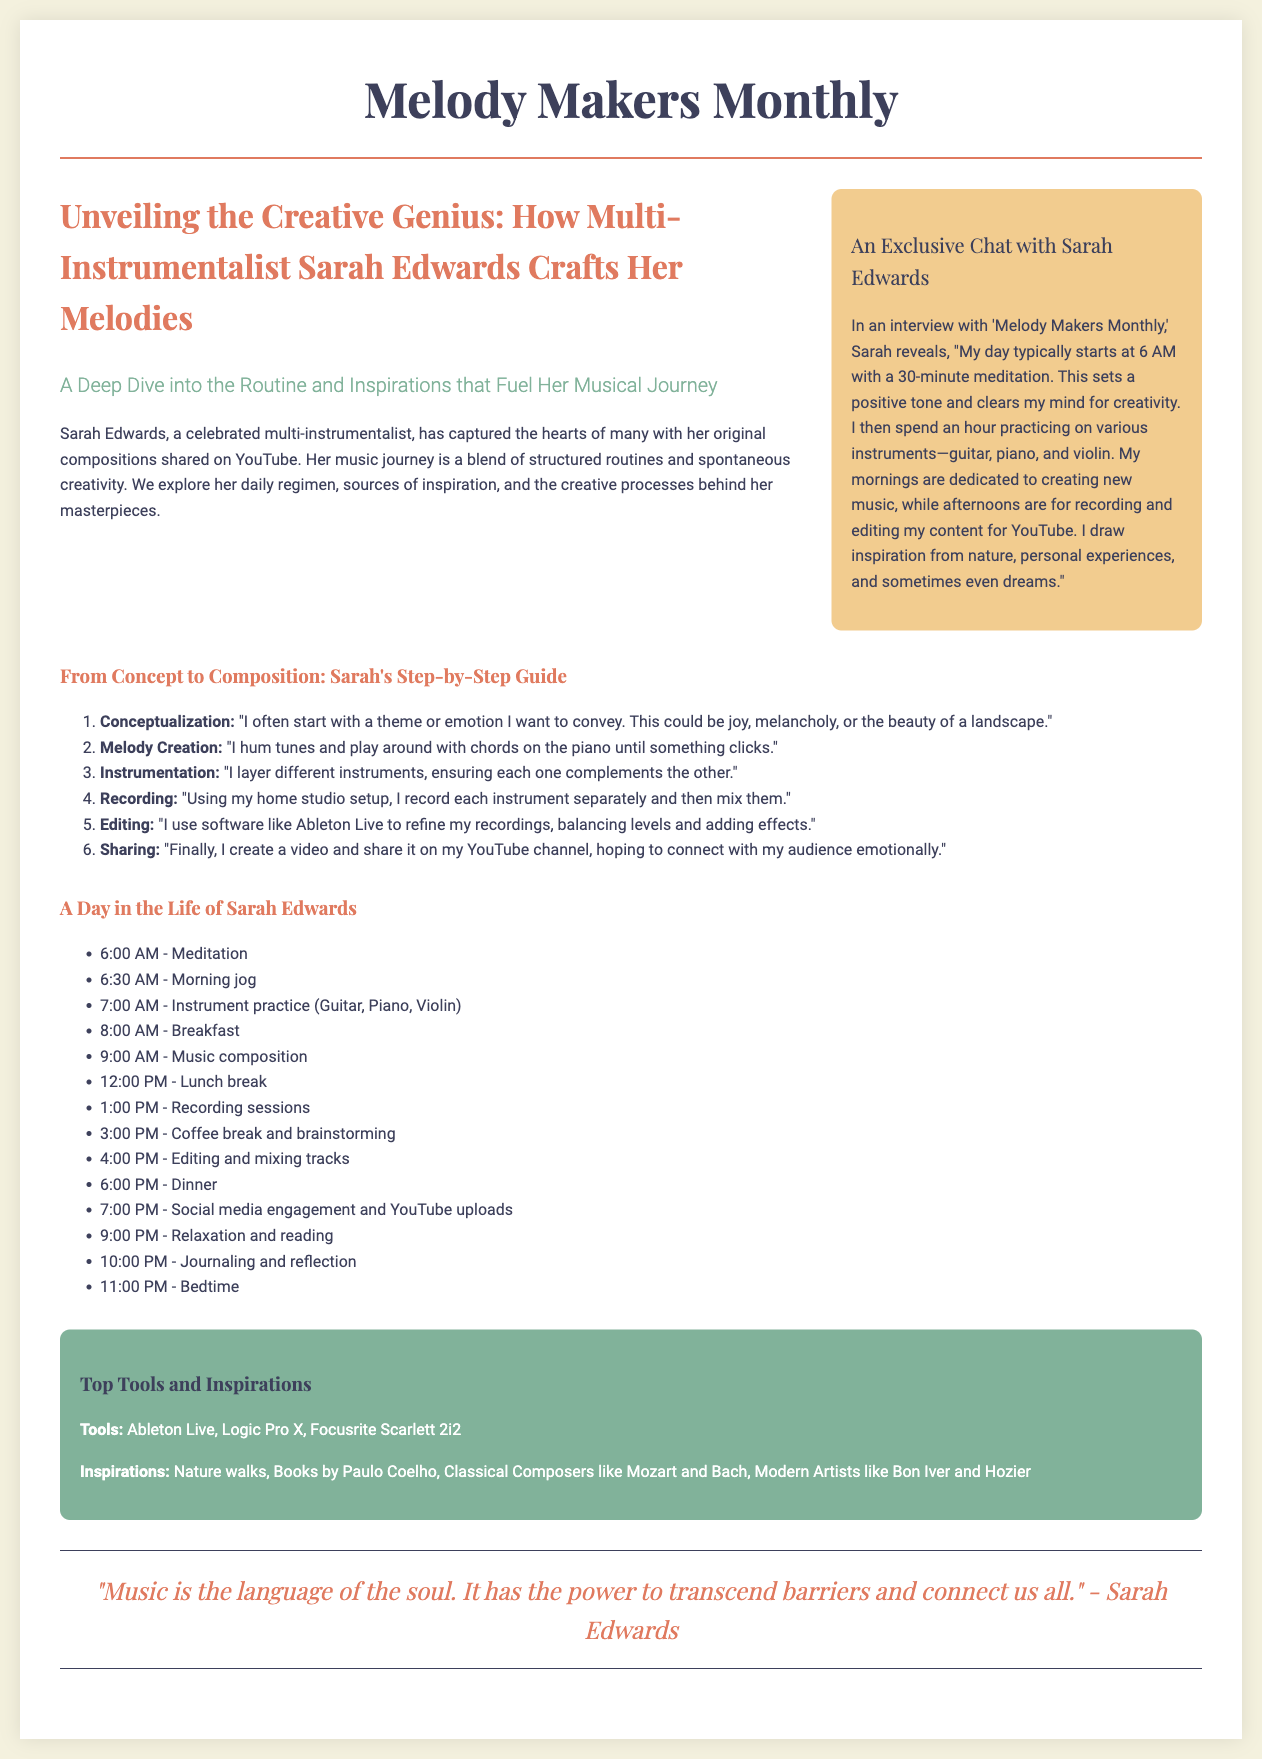what is the name of the featured multi-instrumentalist? The document explicitly identifies Sarah Edwards as the featured multi-instrumentalist.
Answer: Sarah Edwards what time does Sarah start her day? The document states that Sarah's day typically begins at 6 AM.
Answer: 6 AM how many instruments does Sarah practice in the morning? The document mentions that Sarah practices three instruments: guitar, piano, and violin.
Answer: three what tool does Sarah use for refining her recordings? The document specifies that Sarah uses software like Ableton Live for editing her recordings.
Answer: Ableton Live what is the main source of Sarah's inspiration? The document notes that Sarah draws inspiration from nature, personal experiences, and dreams.
Answer: nature, personal experiences, and dreams how does Sarah share her music with the audience? According to the document, Sarah creates a video and shares it on her YouTube channel.
Answer: YouTube channel what is the color of the sidebar in the newspaper layout? The document describes the sidebar as having a background color of green (#81b29a).
Answer: green what is the primary focus of the lead article? The lead article centers around Sarah Edwards' creative processes and daily routines.
Answer: Creative processes and daily routines 